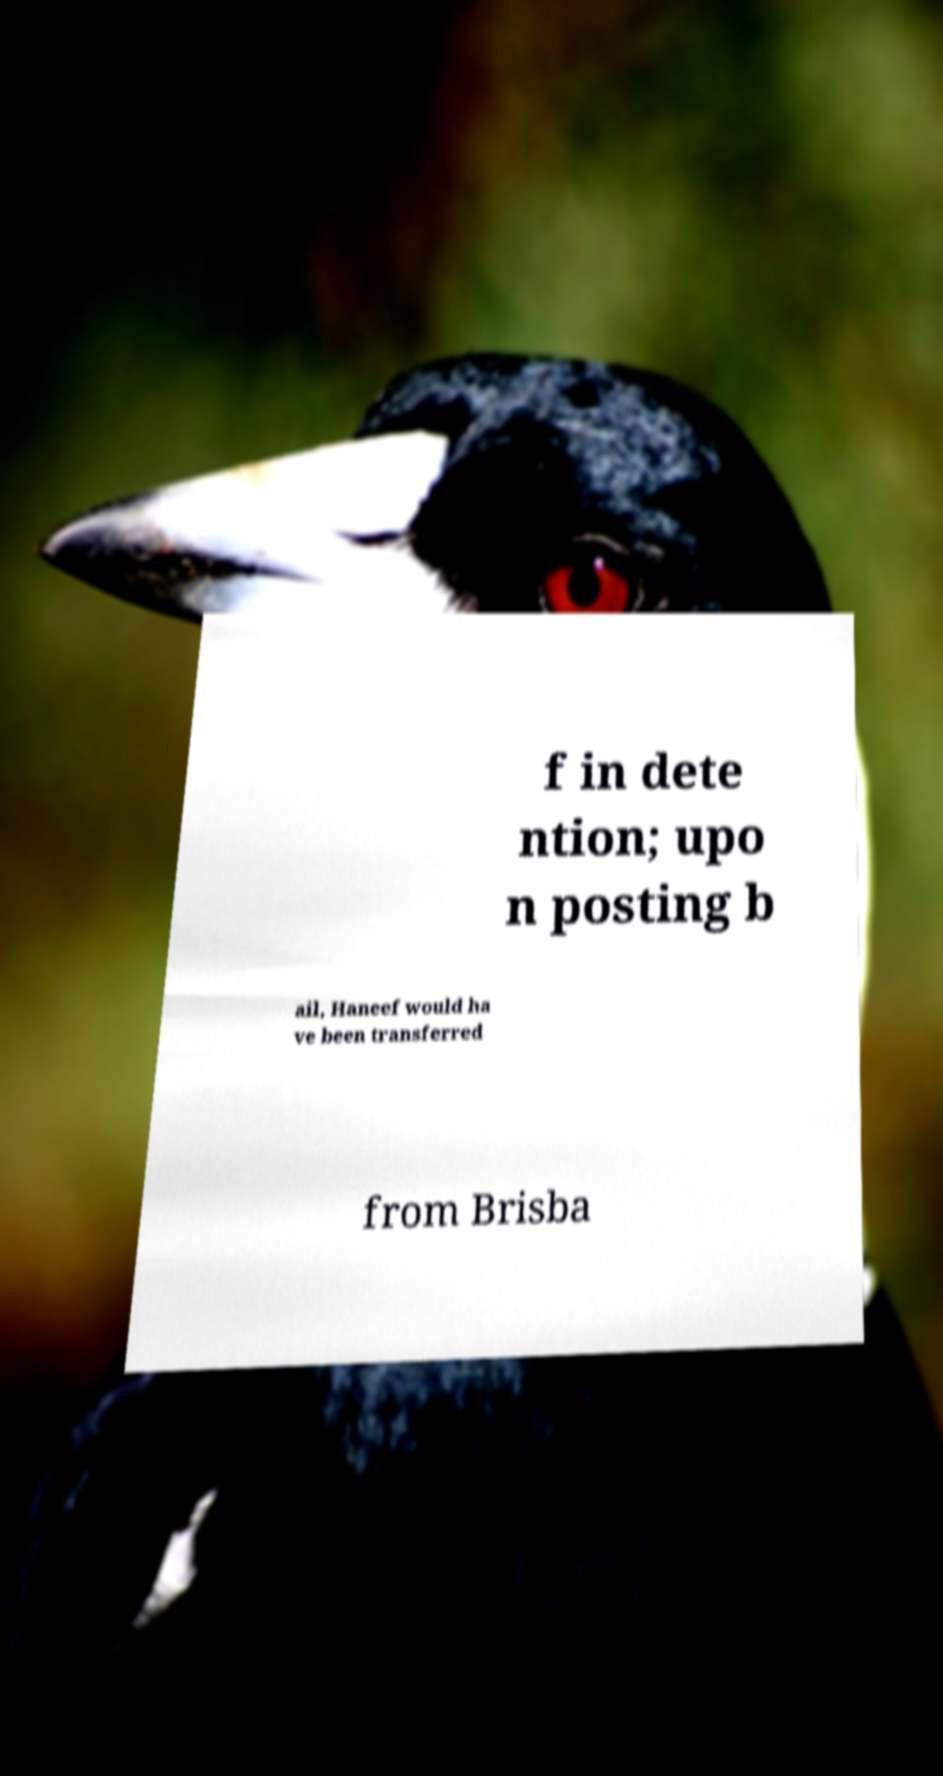Could you extract and type out the text from this image? f in dete ntion; upo n posting b ail, Haneef would ha ve been transferred from Brisba 